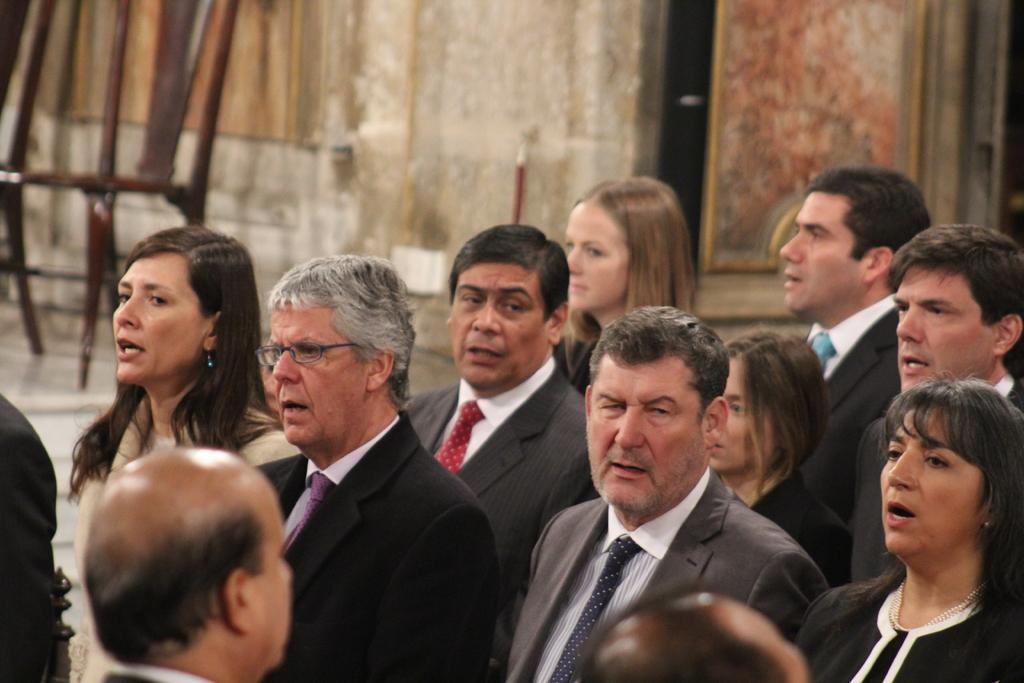How many people are present in the image? There are many people in the image. Can you describe one person's appearance in the image? One person is wearing specs. What can be seen in the background of the image? There is a wall in the background of the image. What type of object is made of wood in the image? There is a wooden object in the image. How would you describe the background's clarity in the image? The background is blurry. What is the average income of the people in the image? There is no information about the people's income in the image. Is there any rain visible in the image? There is no rain visible in the image. 